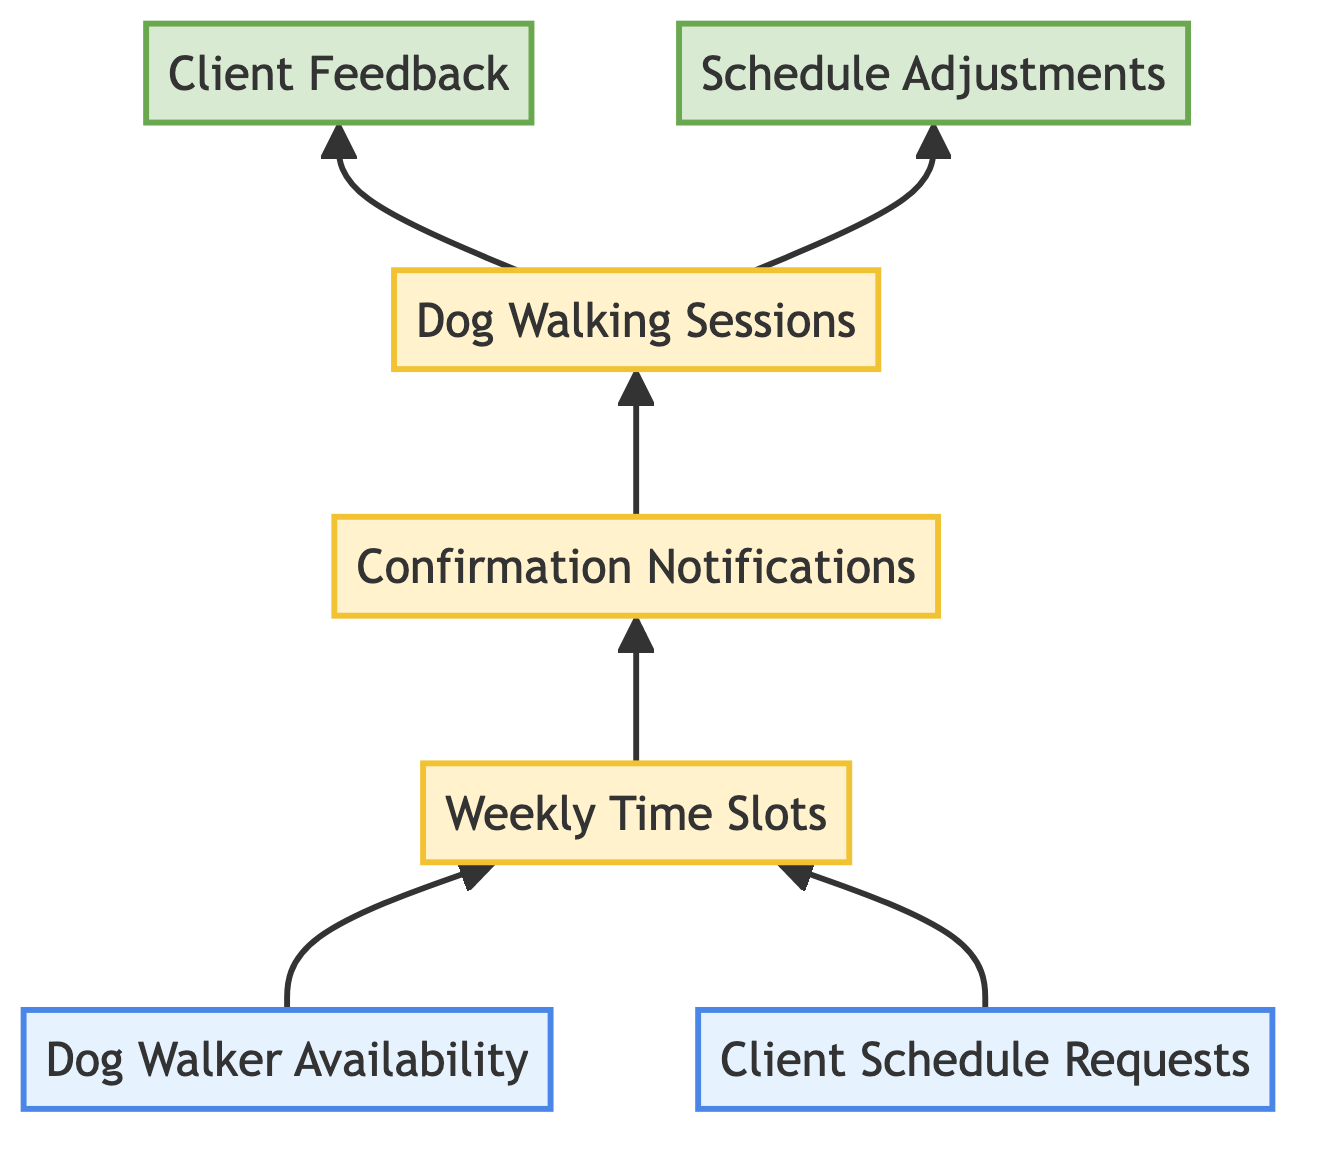What are the two input elements in the diagram? The diagram shows two input elements: "Dog Walker Availability" and "Client Schedule Requests."
Answer: Dog Walker Availability, Client Schedule Requests How many process elements are represented in the diagram? The diagram includes three process elements: "Weekly Time Slots," "Confirmation Notifications," and "Dog Walking Sessions."
Answer: 3 What is the first output element in the diagram? The first output element shown after the dog walking sessions is "Client Feedback."
Answer: Client Feedback Which element directly follows "Weekly Time Slots" in the flow? After "Weekly Time Slots," the following element is "Confirmation Notifications," indicating the next action taken after scheduling.
Answer: Confirmation Notifications If there are changes in the client's needs, which process is affected? Changes in client needs would lead to "Schedule Adjustments," indicating modifications are necessary in the scheduling process.
Answer: Schedule Adjustments What is the link direction from "Client Schedule Requests" to "Weekly Time Slots"? The link from "Client Schedule Requests" to "Weekly Time Slots" is directed, indicating that client requests influence the scheduling of time slots.
Answer: Directed How does "Dog Walker Availability" influence the process? "Dog Walker Availability" impacts the "Weekly Time Slots," as the availability of walkers dictates when slots can be scheduled.
Answer: Weekly Time Slots What happens after "Dog Walking Sessions" are completed? After "Dog Walking Sessions," the outputs are "Client Feedback" and "Schedule Adjustments," showing both feedback and potential schedule changes based on those sessions.
Answer: Client Feedback, Schedule Adjustments 